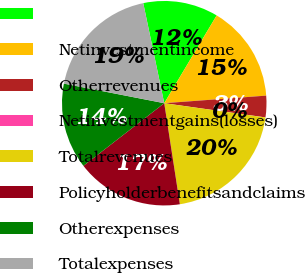<chart> <loc_0><loc_0><loc_500><loc_500><pie_chart><ecel><fcel>Netinvestmentincome<fcel>Otherrevenues<fcel>Netinvestmentgains(losses)<fcel>Totalrevenues<fcel>Policyholderbenefitsandclaims<fcel>Otherexpenses<fcel>Totalexpenses<nl><fcel>11.86%<fcel>15.25%<fcel>3.4%<fcel>0.01%<fcel>20.33%<fcel>16.95%<fcel>13.56%<fcel>18.64%<nl></chart> 